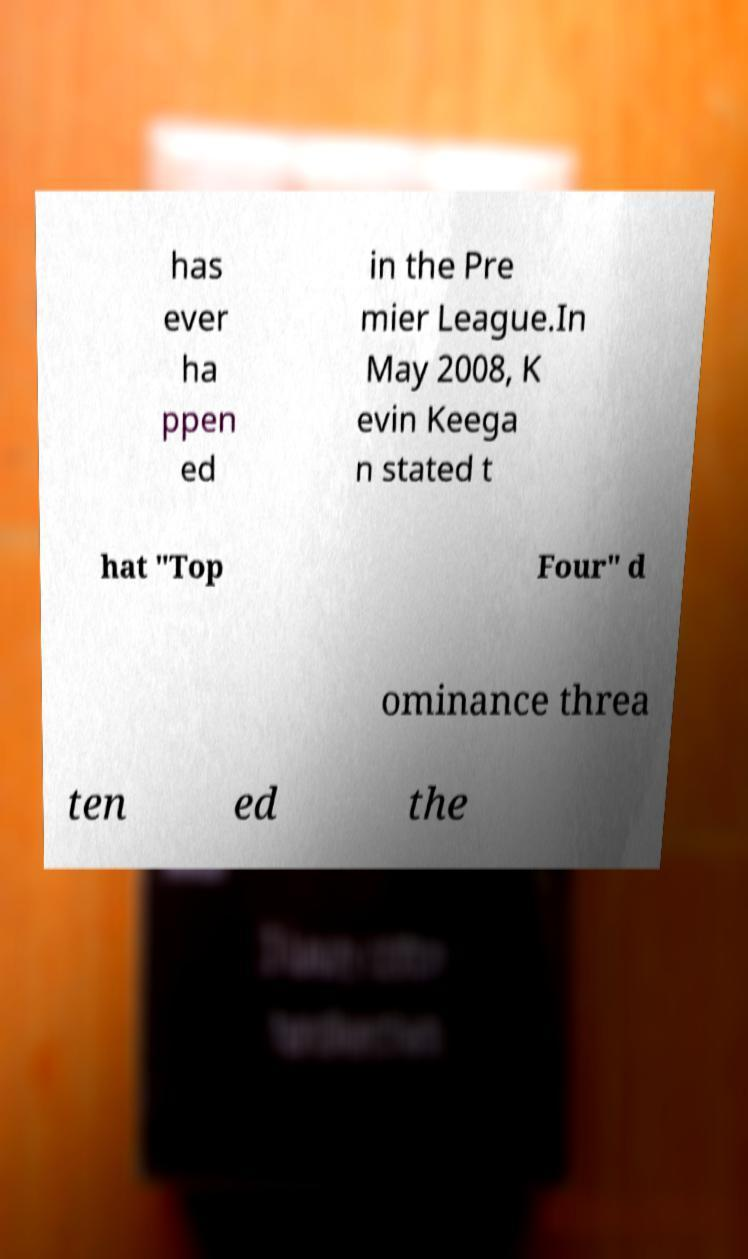For documentation purposes, I need the text within this image transcribed. Could you provide that? has ever ha ppen ed in the Pre mier League.In May 2008, K evin Keega n stated t hat "Top Four" d ominance threa ten ed the 